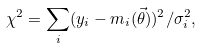Convert formula to latex. <formula><loc_0><loc_0><loc_500><loc_500>\chi ^ { 2 } = \sum _ { i } ( y _ { i } - m _ { i } ( \vec { \theta } ) ) ^ { 2 } / \sigma _ { i } ^ { 2 } ,</formula> 